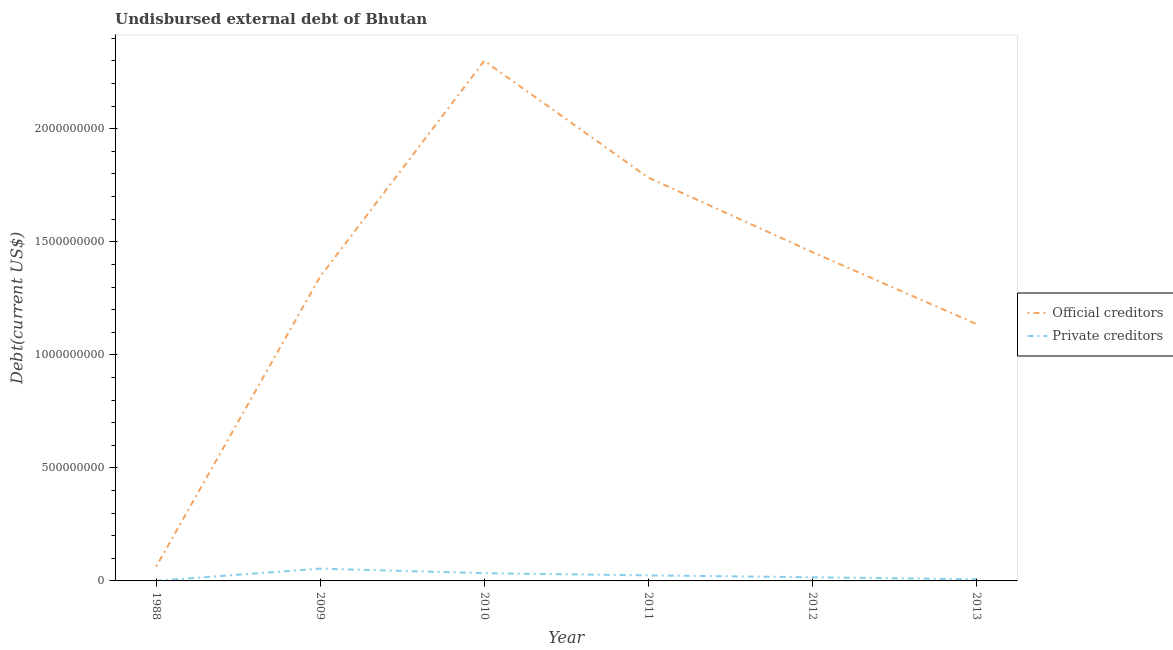How many different coloured lines are there?
Provide a short and direct response. 2. Does the line corresponding to undisbursed external debt of private creditors intersect with the line corresponding to undisbursed external debt of official creditors?
Make the answer very short. No. Is the number of lines equal to the number of legend labels?
Your response must be concise. Yes. What is the undisbursed external debt of private creditors in 1988?
Your answer should be compact. 4.93e+05. Across all years, what is the maximum undisbursed external debt of official creditors?
Keep it short and to the point. 2.30e+09. Across all years, what is the minimum undisbursed external debt of official creditors?
Give a very brief answer. 6.33e+07. In which year was the undisbursed external debt of private creditors minimum?
Ensure brevity in your answer.  1988. What is the total undisbursed external debt of official creditors in the graph?
Offer a terse response. 8.08e+09. What is the difference between the undisbursed external debt of private creditors in 2010 and that in 2012?
Give a very brief answer. 1.80e+07. What is the difference between the undisbursed external debt of private creditors in 2011 and the undisbursed external debt of official creditors in 2009?
Offer a terse response. -1.32e+09. What is the average undisbursed external debt of private creditors per year?
Give a very brief answer. 2.29e+07. In the year 2013, what is the difference between the undisbursed external debt of official creditors and undisbursed external debt of private creditors?
Provide a short and direct response. 1.13e+09. What is the ratio of the undisbursed external debt of official creditors in 2011 to that in 2012?
Make the answer very short. 1.23. Is the difference between the undisbursed external debt of official creditors in 2009 and 2010 greater than the difference between the undisbursed external debt of private creditors in 2009 and 2010?
Ensure brevity in your answer.  No. What is the difference between the highest and the second highest undisbursed external debt of official creditors?
Provide a succinct answer. 5.16e+08. What is the difference between the highest and the lowest undisbursed external debt of official creditors?
Offer a very short reply. 2.24e+09. Does the graph contain grids?
Offer a terse response. No. Where does the legend appear in the graph?
Keep it short and to the point. Center right. What is the title of the graph?
Provide a succinct answer. Undisbursed external debt of Bhutan. What is the label or title of the X-axis?
Make the answer very short. Year. What is the label or title of the Y-axis?
Your response must be concise. Debt(current US$). What is the Debt(current US$) of Official creditors in 1988?
Your answer should be very brief. 6.33e+07. What is the Debt(current US$) in Private creditors in 1988?
Give a very brief answer. 4.93e+05. What is the Debt(current US$) in Official creditors in 2009?
Your response must be concise. 1.35e+09. What is the Debt(current US$) in Private creditors in 2009?
Offer a terse response. 5.43e+07. What is the Debt(current US$) in Official creditors in 2010?
Your answer should be very brief. 2.30e+09. What is the Debt(current US$) in Private creditors in 2010?
Make the answer very short. 3.42e+07. What is the Debt(current US$) of Official creditors in 2011?
Give a very brief answer. 1.78e+09. What is the Debt(current US$) in Private creditors in 2011?
Keep it short and to the point. 2.46e+07. What is the Debt(current US$) in Official creditors in 2012?
Offer a very short reply. 1.45e+09. What is the Debt(current US$) of Private creditors in 2012?
Ensure brevity in your answer.  1.62e+07. What is the Debt(current US$) of Official creditors in 2013?
Your answer should be very brief. 1.14e+09. What is the Debt(current US$) of Private creditors in 2013?
Offer a terse response. 7.40e+06. Across all years, what is the maximum Debt(current US$) in Official creditors?
Offer a very short reply. 2.30e+09. Across all years, what is the maximum Debt(current US$) in Private creditors?
Your answer should be very brief. 5.43e+07. Across all years, what is the minimum Debt(current US$) of Official creditors?
Your answer should be very brief. 6.33e+07. Across all years, what is the minimum Debt(current US$) in Private creditors?
Offer a terse response. 4.93e+05. What is the total Debt(current US$) of Official creditors in the graph?
Offer a very short reply. 8.08e+09. What is the total Debt(current US$) of Private creditors in the graph?
Provide a short and direct response. 1.37e+08. What is the difference between the Debt(current US$) in Official creditors in 1988 and that in 2009?
Your answer should be very brief. -1.28e+09. What is the difference between the Debt(current US$) in Private creditors in 1988 and that in 2009?
Make the answer very short. -5.38e+07. What is the difference between the Debt(current US$) of Official creditors in 1988 and that in 2010?
Provide a succinct answer. -2.24e+09. What is the difference between the Debt(current US$) of Private creditors in 1988 and that in 2010?
Provide a short and direct response. -3.37e+07. What is the difference between the Debt(current US$) in Official creditors in 1988 and that in 2011?
Your answer should be very brief. -1.72e+09. What is the difference between the Debt(current US$) in Private creditors in 1988 and that in 2011?
Offer a very short reply. -2.41e+07. What is the difference between the Debt(current US$) of Official creditors in 1988 and that in 2012?
Ensure brevity in your answer.  -1.39e+09. What is the difference between the Debt(current US$) of Private creditors in 1988 and that in 2012?
Keep it short and to the point. -1.57e+07. What is the difference between the Debt(current US$) in Official creditors in 1988 and that in 2013?
Provide a succinct answer. -1.07e+09. What is the difference between the Debt(current US$) of Private creditors in 1988 and that in 2013?
Your answer should be very brief. -6.91e+06. What is the difference between the Debt(current US$) of Official creditors in 2009 and that in 2010?
Provide a succinct answer. -9.54e+08. What is the difference between the Debt(current US$) in Private creditors in 2009 and that in 2010?
Your answer should be compact. 2.01e+07. What is the difference between the Debt(current US$) of Official creditors in 2009 and that in 2011?
Keep it short and to the point. -4.37e+08. What is the difference between the Debt(current US$) in Private creditors in 2009 and that in 2011?
Give a very brief answer. 2.97e+07. What is the difference between the Debt(current US$) of Official creditors in 2009 and that in 2012?
Provide a short and direct response. -1.08e+08. What is the difference between the Debt(current US$) in Private creditors in 2009 and that in 2012?
Offer a very short reply. 3.81e+07. What is the difference between the Debt(current US$) of Official creditors in 2009 and that in 2013?
Your answer should be very brief. 2.10e+08. What is the difference between the Debt(current US$) of Private creditors in 2009 and that in 2013?
Provide a short and direct response. 4.69e+07. What is the difference between the Debt(current US$) of Official creditors in 2010 and that in 2011?
Keep it short and to the point. 5.16e+08. What is the difference between the Debt(current US$) of Private creditors in 2010 and that in 2011?
Offer a very short reply. 9.60e+06. What is the difference between the Debt(current US$) of Official creditors in 2010 and that in 2012?
Your response must be concise. 8.46e+08. What is the difference between the Debt(current US$) of Private creditors in 2010 and that in 2012?
Provide a short and direct response. 1.80e+07. What is the difference between the Debt(current US$) in Official creditors in 2010 and that in 2013?
Give a very brief answer. 1.16e+09. What is the difference between the Debt(current US$) in Private creditors in 2010 and that in 2013?
Provide a short and direct response. 2.68e+07. What is the difference between the Debt(current US$) of Official creditors in 2011 and that in 2012?
Your response must be concise. 3.29e+08. What is the difference between the Debt(current US$) in Private creditors in 2011 and that in 2012?
Provide a short and direct response. 8.43e+06. What is the difference between the Debt(current US$) in Official creditors in 2011 and that in 2013?
Provide a succinct answer. 6.48e+08. What is the difference between the Debt(current US$) in Private creditors in 2011 and that in 2013?
Your answer should be compact. 1.72e+07. What is the difference between the Debt(current US$) of Official creditors in 2012 and that in 2013?
Ensure brevity in your answer.  3.18e+08. What is the difference between the Debt(current US$) in Private creditors in 2012 and that in 2013?
Offer a terse response. 8.79e+06. What is the difference between the Debt(current US$) of Official creditors in 1988 and the Debt(current US$) of Private creditors in 2009?
Make the answer very short. 8.98e+06. What is the difference between the Debt(current US$) in Official creditors in 1988 and the Debt(current US$) in Private creditors in 2010?
Your answer should be compact. 2.91e+07. What is the difference between the Debt(current US$) in Official creditors in 1988 and the Debt(current US$) in Private creditors in 2011?
Ensure brevity in your answer.  3.87e+07. What is the difference between the Debt(current US$) in Official creditors in 1988 and the Debt(current US$) in Private creditors in 2012?
Offer a very short reply. 4.71e+07. What is the difference between the Debt(current US$) of Official creditors in 1988 and the Debt(current US$) of Private creditors in 2013?
Ensure brevity in your answer.  5.59e+07. What is the difference between the Debt(current US$) in Official creditors in 2009 and the Debt(current US$) in Private creditors in 2010?
Your answer should be compact. 1.31e+09. What is the difference between the Debt(current US$) in Official creditors in 2009 and the Debt(current US$) in Private creditors in 2011?
Keep it short and to the point. 1.32e+09. What is the difference between the Debt(current US$) of Official creditors in 2009 and the Debt(current US$) of Private creditors in 2012?
Your response must be concise. 1.33e+09. What is the difference between the Debt(current US$) in Official creditors in 2009 and the Debt(current US$) in Private creditors in 2013?
Your answer should be compact. 1.34e+09. What is the difference between the Debt(current US$) of Official creditors in 2010 and the Debt(current US$) of Private creditors in 2011?
Offer a terse response. 2.28e+09. What is the difference between the Debt(current US$) in Official creditors in 2010 and the Debt(current US$) in Private creditors in 2012?
Give a very brief answer. 2.28e+09. What is the difference between the Debt(current US$) of Official creditors in 2010 and the Debt(current US$) of Private creditors in 2013?
Provide a succinct answer. 2.29e+09. What is the difference between the Debt(current US$) of Official creditors in 2011 and the Debt(current US$) of Private creditors in 2012?
Offer a terse response. 1.77e+09. What is the difference between the Debt(current US$) in Official creditors in 2011 and the Debt(current US$) in Private creditors in 2013?
Your answer should be compact. 1.78e+09. What is the difference between the Debt(current US$) of Official creditors in 2012 and the Debt(current US$) of Private creditors in 2013?
Offer a terse response. 1.45e+09. What is the average Debt(current US$) of Official creditors per year?
Make the answer very short. 1.35e+09. What is the average Debt(current US$) of Private creditors per year?
Your answer should be very brief. 2.29e+07. In the year 1988, what is the difference between the Debt(current US$) of Official creditors and Debt(current US$) of Private creditors?
Offer a very short reply. 6.28e+07. In the year 2009, what is the difference between the Debt(current US$) of Official creditors and Debt(current US$) of Private creditors?
Offer a terse response. 1.29e+09. In the year 2010, what is the difference between the Debt(current US$) of Official creditors and Debt(current US$) of Private creditors?
Offer a very short reply. 2.27e+09. In the year 2011, what is the difference between the Debt(current US$) of Official creditors and Debt(current US$) of Private creditors?
Offer a very short reply. 1.76e+09. In the year 2012, what is the difference between the Debt(current US$) of Official creditors and Debt(current US$) of Private creditors?
Provide a succinct answer. 1.44e+09. In the year 2013, what is the difference between the Debt(current US$) in Official creditors and Debt(current US$) in Private creditors?
Keep it short and to the point. 1.13e+09. What is the ratio of the Debt(current US$) of Official creditors in 1988 to that in 2009?
Provide a short and direct response. 0.05. What is the ratio of the Debt(current US$) in Private creditors in 1988 to that in 2009?
Make the answer very short. 0.01. What is the ratio of the Debt(current US$) of Official creditors in 1988 to that in 2010?
Your answer should be very brief. 0.03. What is the ratio of the Debt(current US$) of Private creditors in 1988 to that in 2010?
Provide a succinct answer. 0.01. What is the ratio of the Debt(current US$) of Official creditors in 1988 to that in 2011?
Give a very brief answer. 0.04. What is the ratio of the Debt(current US$) in Official creditors in 1988 to that in 2012?
Ensure brevity in your answer.  0.04. What is the ratio of the Debt(current US$) in Private creditors in 1988 to that in 2012?
Ensure brevity in your answer.  0.03. What is the ratio of the Debt(current US$) of Official creditors in 1988 to that in 2013?
Provide a short and direct response. 0.06. What is the ratio of the Debt(current US$) in Private creditors in 1988 to that in 2013?
Offer a terse response. 0.07. What is the ratio of the Debt(current US$) in Official creditors in 2009 to that in 2010?
Provide a short and direct response. 0.59. What is the ratio of the Debt(current US$) in Private creditors in 2009 to that in 2010?
Give a very brief answer. 1.59. What is the ratio of the Debt(current US$) of Official creditors in 2009 to that in 2011?
Offer a very short reply. 0.75. What is the ratio of the Debt(current US$) of Private creditors in 2009 to that in 2011?
Your response must be concise. 2.21. What is the ratio of the Debt(current US$) in Official creditors in 2009 to that in 2012?
Ensure brevity in your answer.  0.93. What is the ratio of the Debt(current US$) in Private creditors in 2009 to that in 2012?
Give a very brief answer. 3.36. What is the ratio of the Debt(current US$) in Official creditors in 2009 to that in 2013?
Offer a terse response. 1.19. What is the ratio of the Debt(current US$) in Private creditors in 2009 to that in 2013?
Provide a short and direct response. 7.34. What is the ratio of the Debt(current US$) in Official creditors in 2010 to that in 2011?
Give a very brief answer. 1.29. What is the ratio of the Debt(current US$) in Private creditors in 2010 to that in 2011?
Your answer should be compact. 1.39. What is the ratio of the Debt(current US$) in Official creditors in 2010 to that in 2012?
Provide a succinct answer. 1.58. What is the ratio of the Debt(current US$) of Private creditors in 2010 to that in 2012?
Your response must be concise. 2.11. What is the ratio of the Debt(current US$) of Official creditors in 2010 to that in 2013?
Provide a short and direct response. 2.02. What is the ratio of the Debt(current US$) of Private creditors in 2010 to that in 2013?
Your answer should be compact. 4.62. What is the ratio of the Debt(current US$) in Official creditors in 2011 to that in 2012?
Keep it short and to the point. 1.23. What is the ratio of the Debt(current US$) in Private creditors in 2011 to that in 2012?
Offer a very short reply. 1.52. What is the ratio of the Debt(current US$) in Official creditors in 2011 to that in 2013?
Your answer should be compact. 1.57. What is the ratio of the Debt(current US$) in Private creditors in 2011 to that in 2013?
Provide a short and direct response. 3.33. What is the ratio of the Debt(current US$) in Official creditors in 2012 to that in 2013?
Give a very brief answer. 1.28. What is the ratio of the Debt(current US$) in Private creditors in 2012 to that in 2013?
Provide a succinct answer. 2.19. What is the difference between the highest and the second highest Debt(current US$) of Official creditors?
Keep it short and to the point. 5.16e+08. What is the difference between the highest and the second highest Debt(current US$) of Private creditors?
Give a very brief answer. 2.01e+07. What is the difference between the highest and the lowest Debt(current US$) in Official creditors?
Your answer should be very brief. 2.24e+09. What is the difference between the highest and the lowest Debt(current US$) of Private creditors?
Keep it short and to the point. 5.38e+07. 